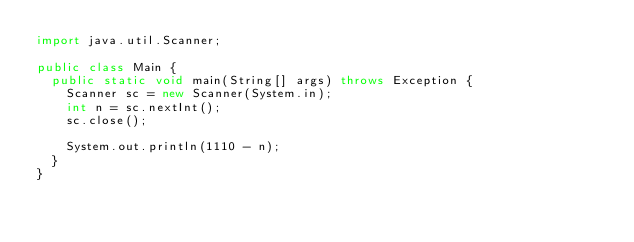Convert code to text. <code><loc_0><loc_0><loc_500><loc_500><_Java_>import java.util.Scanner;

public class Main {
	public static void main(String[] args) throws Exception {
		Scanner sc = new Scanner(System.in);
		int n = sc.nextInt();
		sc.close();

		System.out.println(1110 - n);
	}
}
</code> 